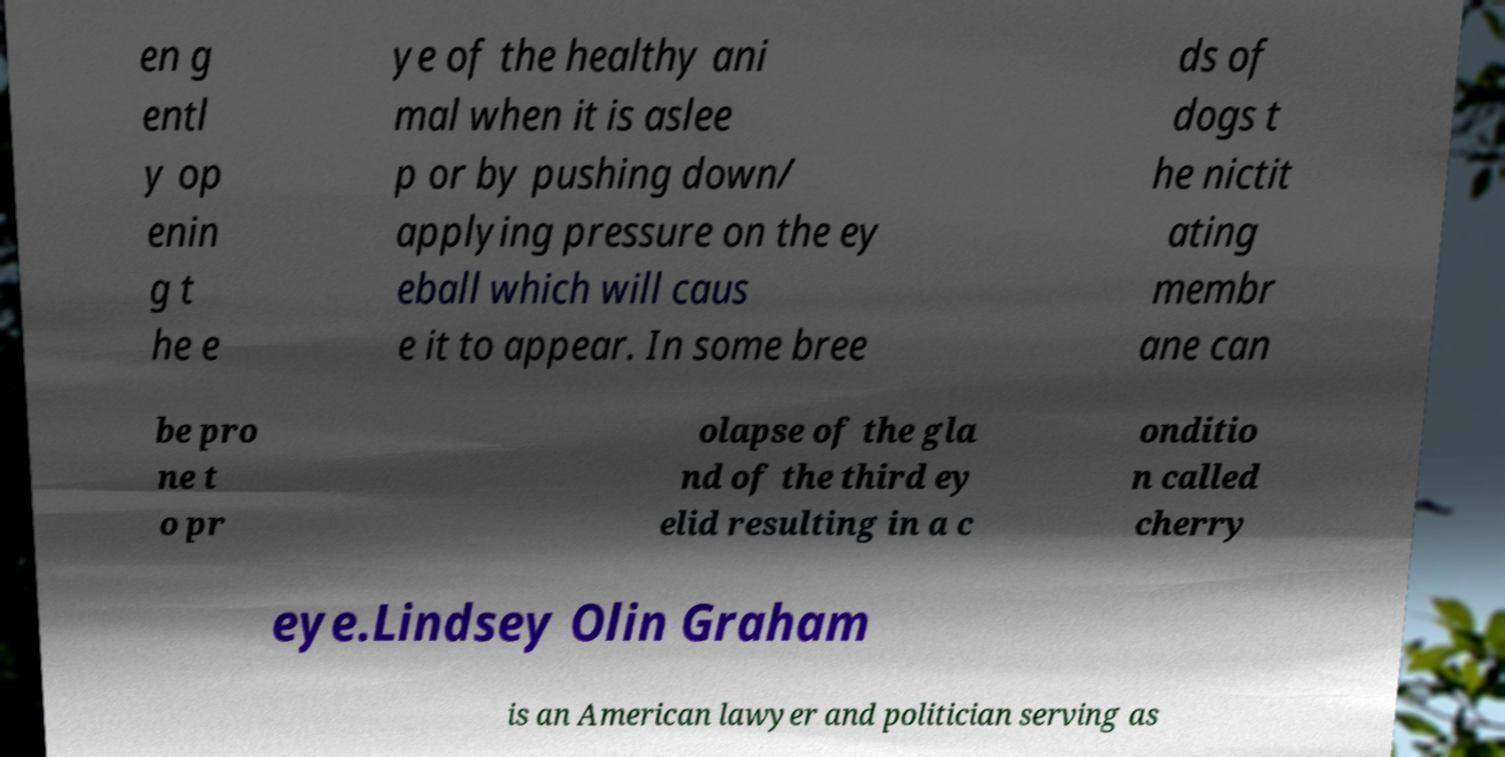There's text embedded in this image that I need extracted. Can you transcribe it verbatim? en g entl y op enin g t he e ye of the healthy ani mal when it is aslee p or by pushing down/ applying pressure on the ey eball which will caus e it to appear. In some bree ds of dogs t he nictit ating membr ane can be pro ne t o pr olapse of the gla nd of the third ey elid resulting in a c onditio n called cherry eye.Lindsey Olin Graham is an American lawyer and politician serving as 